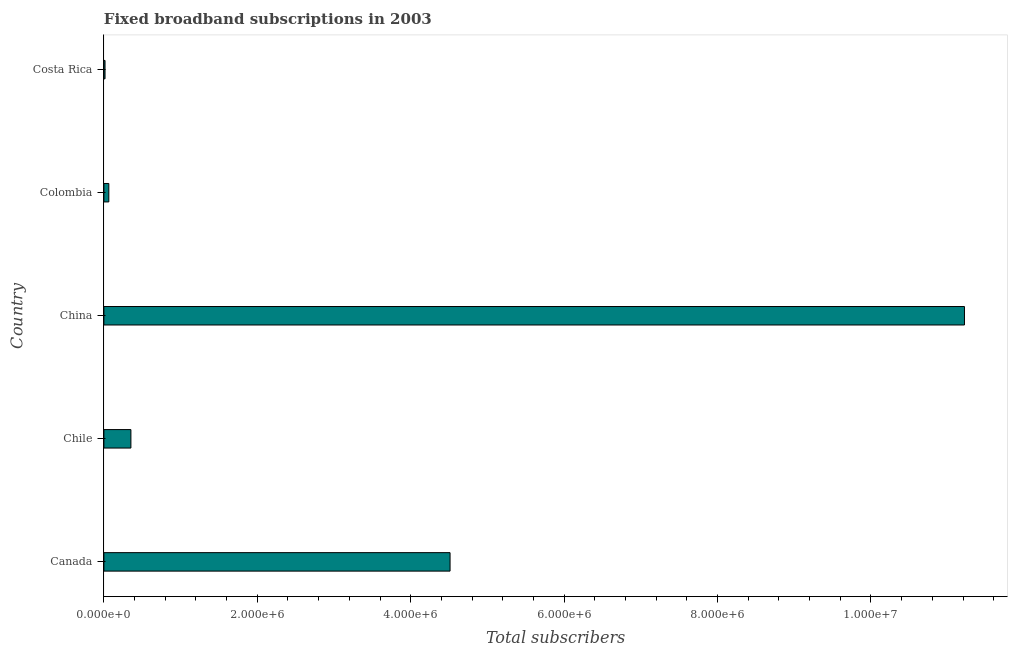What is the title of the graph?
Your response must be concise. Fixed broadband subscriptions in 2003. What is the label or title of the X-axis?
Provide a short and direct response. Total subscribers. What is the total number of fixed broadband subscriptions in China?
Ensure brevity in your answer.  1.12e+07. Across all countries, what is the maximum total number of fixed broadband subscriptions?
Offer a very short reply. 1.12e+07. Across all countries, what is the minimum total number of fixed broadband subscriptions?
Provide a short and direct response. 1.49e+04. In which country was the total number of fixed broadband subscriptions minimum?
Ensure brevity in your answer.  Costa Rica. What is the sum of the total number of fixed broadband subscriptions?
Make the answer very short. 1.62e+07. What is the difference between the total number of fixed broadband subscriptions in China and Costa Rica?
Your answer should be compact. 1.12e+07. What is the average total number of fixed broadband subscriptions per country?
Your answer should be compact. 3.23e+06. What is the median total number of fixed broadband subscriptions?
Offer a terse response. 3.52e+05. What is the ratio of the total number of fixed broadband subscriptions in China to that in Colombia?
Ensure brevity in your answer.  174.11. What is the difference between the highest and the second highest total number of fixed broadband subscriptions?
Ensure brevity in your answer.  6.71e+06. Is the sum of the total number of fixed broadband subscriptions in Chile and Costa Rica greater than the maximum total number of fixed broadband subscriptions across all countries?
Provide a succinct answer. No. What is the difference between the highest and the lowest total number of fixed broadband subscriptions?
Your response must be concise. 1.12e+07. In how many countries, is the total number of fixed broadband subscriptions greater than the average total number of fixed broadband subscriptions taken over all countries?
Give a very brief answer. 2. How many countries are there in the graph?
Make the answer very short. 5. What is the difference between two consecutive major ticks on the X-axis?
Give a very brief answer. 2.00e+06. Are the values on the major ticks of X-axis written in scientific E-notation?
Offer a terse response. Yes. What is the Total subscribers in Canada?
Make the answer very short. 4.51e+06. What is the Total subscribers in Chile?
Provide a short and direct response. 3.52e+05. What is the Total subscribers of China?
Keep it short and to the point. 1.12e+07. What is the Total subscribers in Colombia?
Ensure brevity in your answer.  6.44e+04. What is the Total subscribers of Costa Rica?
Your answer should be very brief. 1.49e+04. What is the difference between the Total subscribers in Canada and Chile?
Give a very brief answer. 4.16e+06. What is the difference between the Total subscribers in Canada and China?
Provide a short and direct response. -6.71e+06. What is the difference between the Total subscribers in Canada and Colombia?
Your response must be concise. 4.45e+06. What is the difference between the Total subscribers in Canada and Costa Rica?
Offer a very short reply. 4.50e+06. What is the difference between the Total subscribers in Chile and China?
Your answer should be very brief. -1.09e+07. What is the difference between the Total subscribers in Chile and Colombia?
Make the answer very short. 2.88e+05. What is the difference between the Total subscribers in Chile and Costa Rica?
Offer a terse response. 3.37e+05. What is the difference between the Total subscribers in China and Colombia?
Your answer should be very brief. 1.12e+07. What is the difference between the Total subscribers in China and Costa Rica?
Provide a short and direct response. 1.12e+07. What is the difference between the Total subscribers in Colombia and Costa Rica?
Your answer should be very brief. 4.96e+04. What is the ratio of the Total subscribers in Canada to that in Chile?
Your answer should be very brief. 12.81. What is the ratio of the Total subscribers in Canada to that in China?
Offer a terse response. 0.4. What is the ratio of the Total subscribers in Canada to that in Colombia?
Offer a very short reply. 70.04. What is the ratio of the Total subscribers in Canada to that in Costa Rica?
Provide a short and direct response. 303.33. What is the ratio of the Total subscribers in Chile to that in China?
Give a very brief answer. 0.03. What is the ratio of the Total subscribers in Chile to that in Colombia?
Provide a short and direct response. 5.47. What is the ratio of the Total subscribers in Chile to that in Costa Rica?
Your answer should be very brief. 23.68. What is the ratio of the Total subscribers in China to that in Colombia?
Give a very brief answer. 174.11. What is the ratio of the Total subscribers in China to that in Costa Rica?
Make the answer very short. 754.07. What is the ratio of the Total subscribers in Colombia to that in Costa Rica?
Make the answer very short. 4.33. 